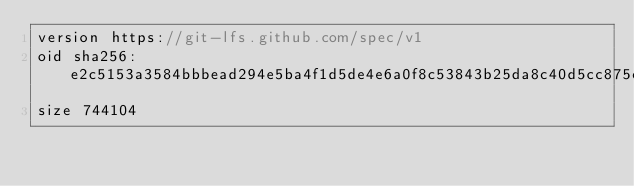<code> <loc_0><loc_0><loc_500><loc_500><_TypeScript_>version https://git-lfs.github.com/spec/v1
oid sha256:e2c5153a3584bbbead294e5ba4f1d5de4e6a0f8c53843b25da8c40d5cc875eaa
size 744104
</code> 